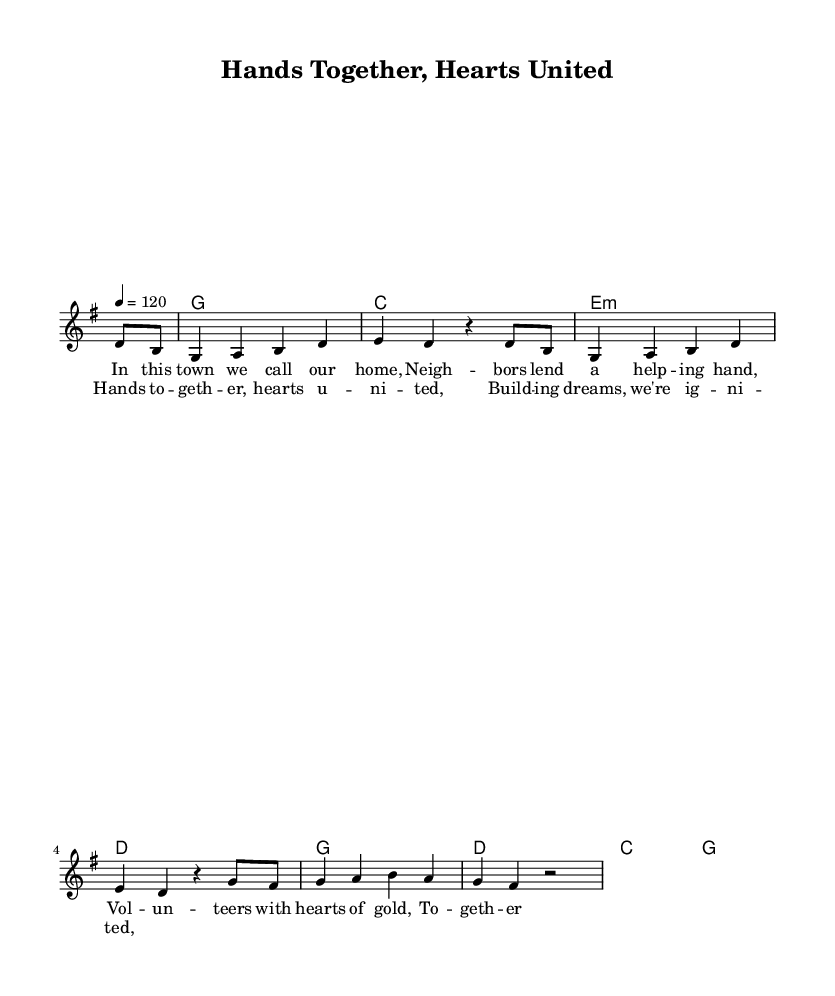What is the key signature of this music? The key signature is G major, which has one sharp (F#). This is indicated at the beginning of the staff, where G major is specified.
Answer: G major What is the time signature of this music? The time signature is 4/4, which means there are four beats per measure and a quarter note receives one beat. This is noted at the beginning of the music.
Answer: 4/4 What is the tempo of the piece? The tempo marking is 120 beats per minute, indicated as "4 = 120" in the tempo section. This signifies that there are 120 quarter note beats in one minute.
Answer: 120 How many measures are in the verse? The verse consists of four measures, as evidenced by counting each measure in the melody line with lyrics underneath, from the start of the verse to its end.
Answer: 4 What is the primary theme of the song? The primary theme revolves around community spirit and volunteerism, as expressed in the lyrics that highlight neighbors helping each other and coming together.
Answer: Community spirit Which chord is used in the first measure? The chord in the first measure is a G major chord, as noted in the harmonies section, specifically the "g1" entry.
Answer: G What type of song structure is used in this piece? The piece utilizes a verse-chorus structure, where a verse is followed by a chorus, repeating a common format seen in country rock songs.
Answer: Verse-chorus 